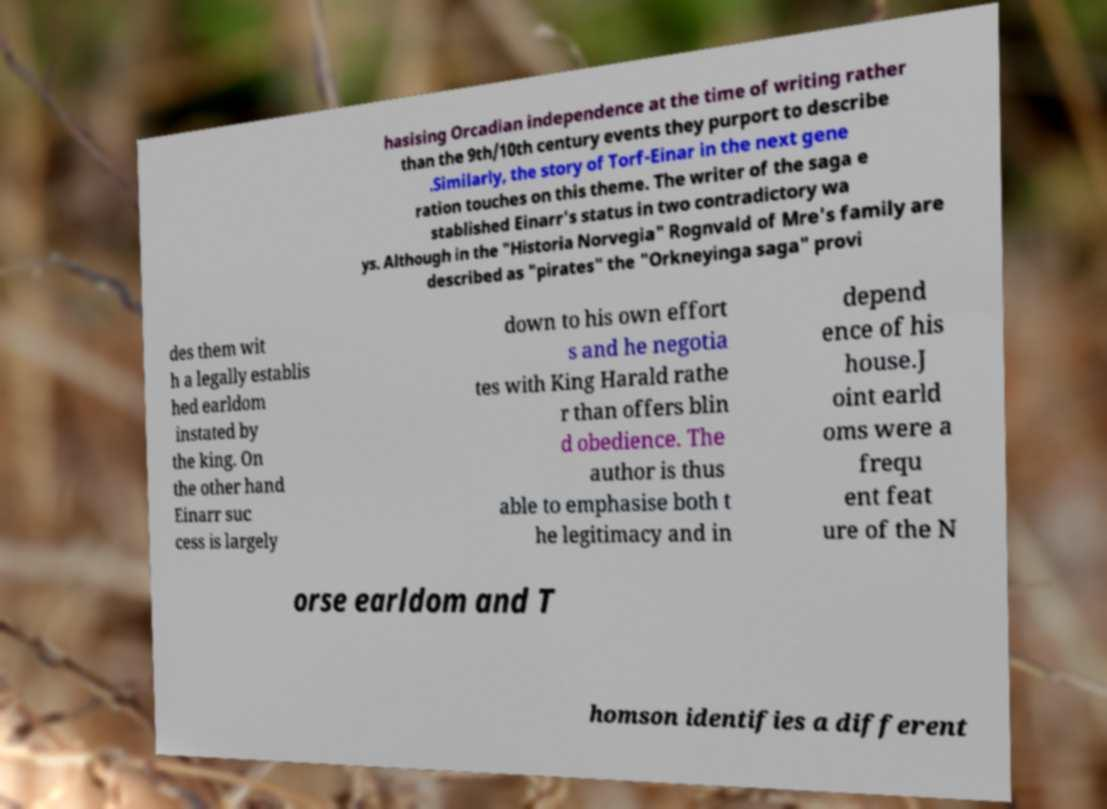There's text embedded in this image that I need extracted. Can you transcribe it verbatim? hasising Orcadian independence at the time of writing rather than the 9th/10th century events they purport to describe .Similarly, the story of Torf-Einar in the next gene ration touches on this theme. The writer of the saga e stablished Einarr's status in two contradictory wa ys. Although in the "Historia Norvegia" Rognvald of Mre's family are described as "pirates" the "Orkneyinga saga" provi des them wit h a legally establis hed earldom instated by the king. On the other hand Einarr suc cess is largely down to his own effort s and he negotia tes with King Harald rathe r than offers blin d obedience. The author is thus able to emphasise both t he legitimacy and in depend ence of his house.J oint earld oms were a frequ ent feat ure of the N orse earldom and T homson identifies a different 